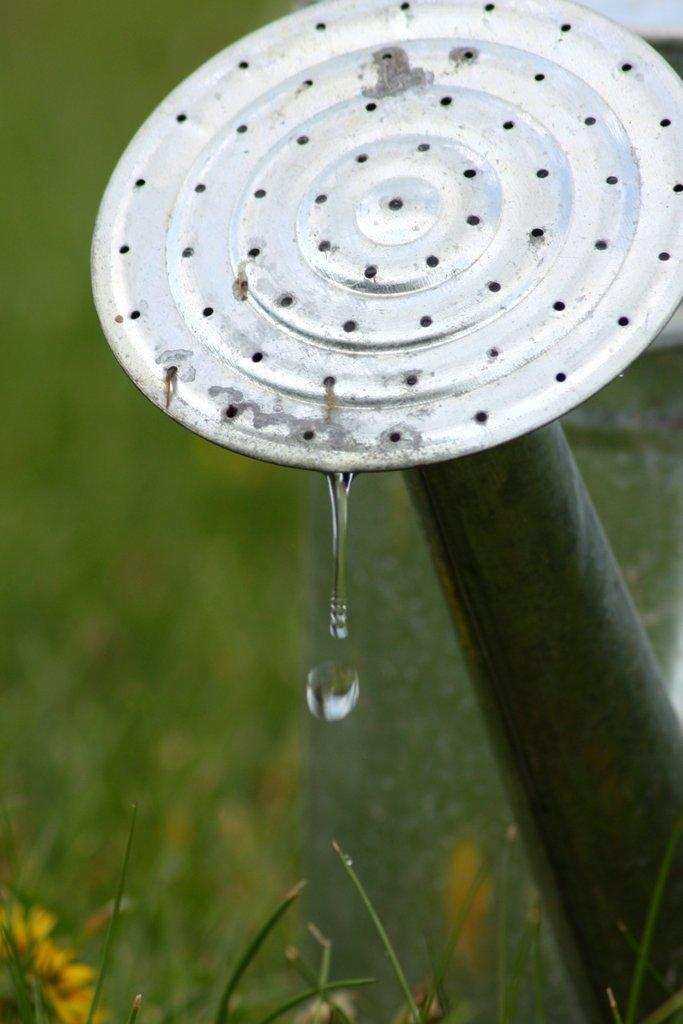What can be seen in the image that is used for cleaning oneself? There is a shower in the image that is used for cleaning oneself. What is the small, round object in the image? There is a water drop in the image. What type of vegetation is present in the image? There are plants in the image. What type of flowers can be seen in the image? There are flowers in the image. What sign is hanging on the wall in the image? There is no sign hanging on the wall in the image. How many teeth can be seen in the image? There are no teeth present in the image. 